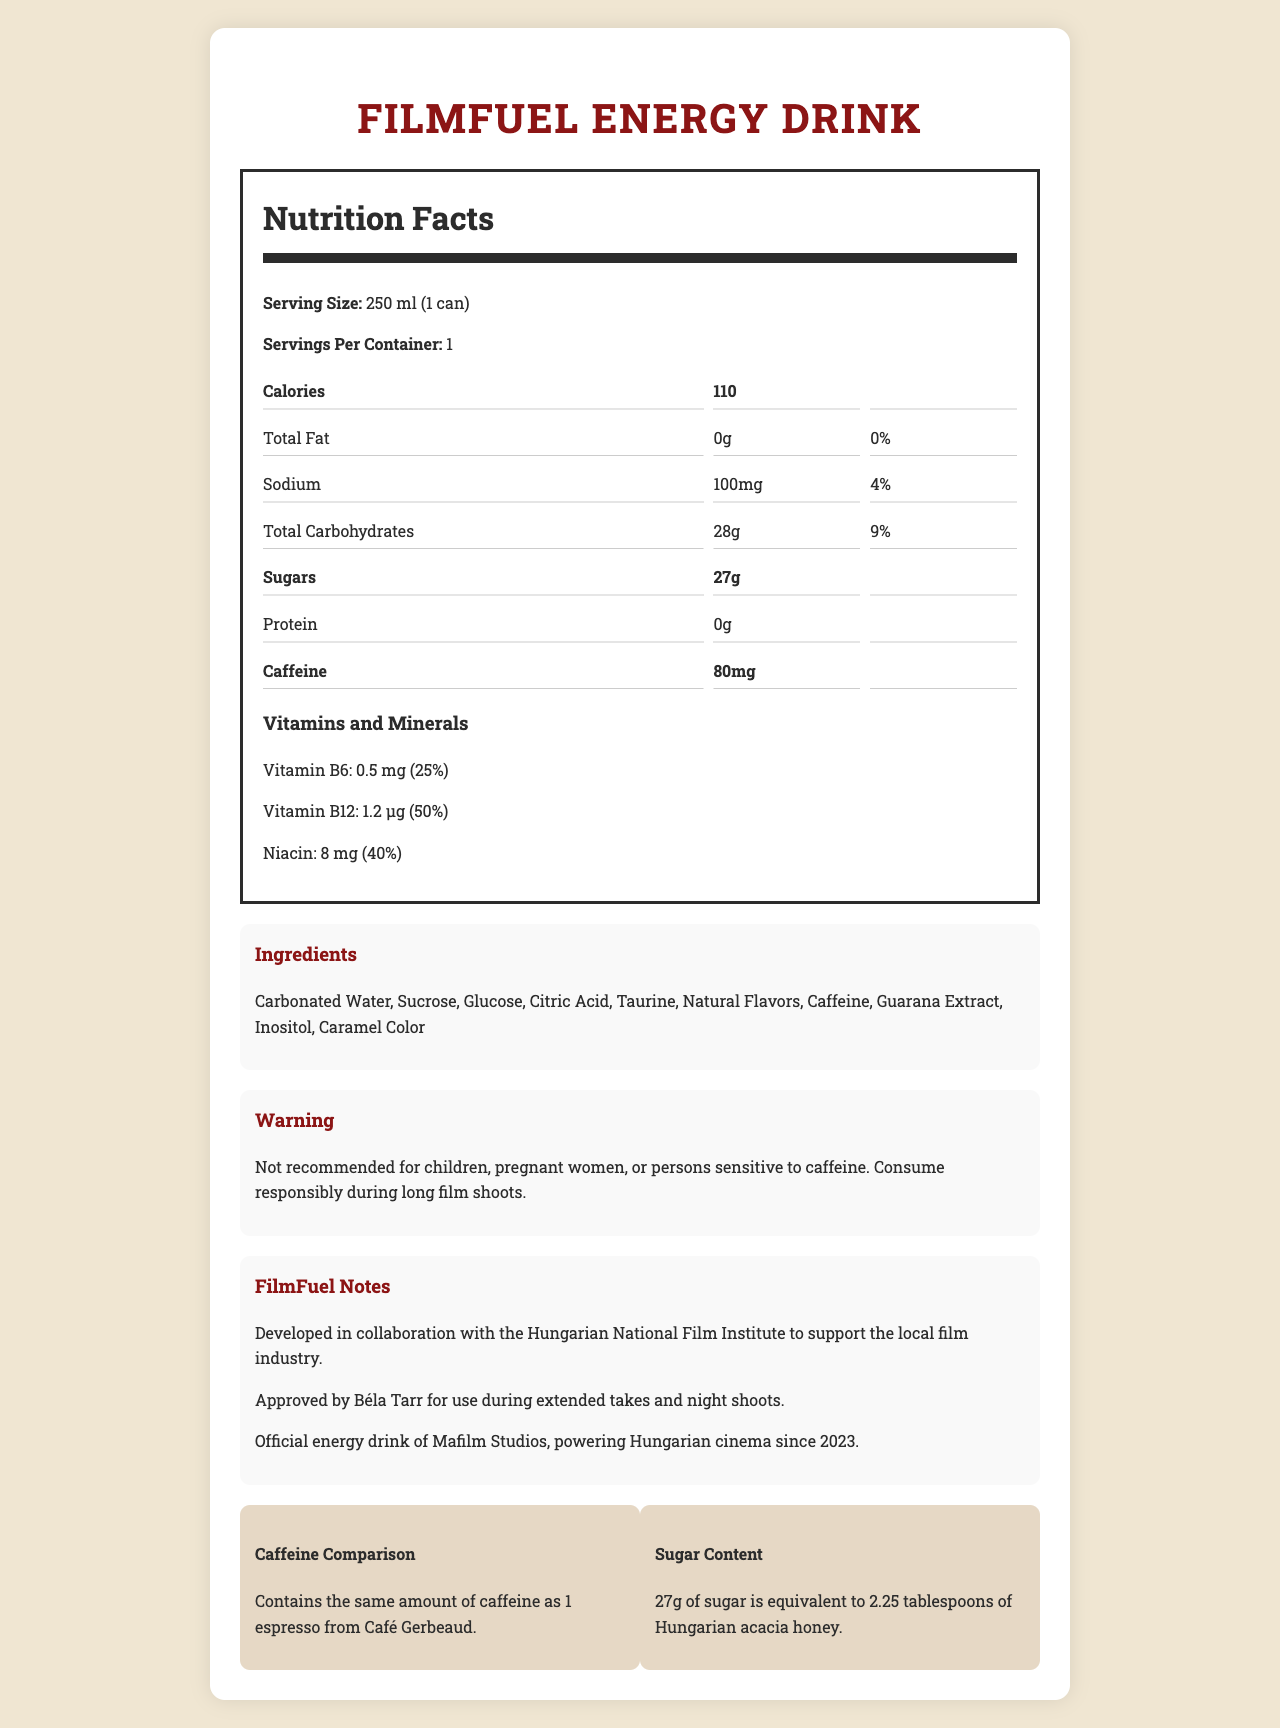How many milligrams of caffeine are in one serving of FilmFuel Energy Drink? The nutrition facts label clearly states that one serving of FilmFuel Energy Drink contains 80 mg of caffeine.
Answer: 80 mg What is the serving size of FilmFuel Energy Drink? The label specifies that the serving size is 250 ml, which is equivalent to one can.
Answer: 250 ml (1 can) How many grams of sugar are in one can of FilmFuel Energy Drink? According to the nutrition facts label, there are 27 grams of sugar in one can of FilmFuel Energy Drink.
Answer: 27 grams What percentage of the daily value of Vitamin B12 does one serving of FilmFuel Energy Drink provide? The nutrition facts label shows that one serving provides 50% of the daily value of Vitamin B12.
Answer: 50% What is one caution given about drinking FilmFuel Energy Drink? The warning section states that the drink is not recommended for children, pregnant women, or persons sensitive to caffeine.
Answer: Not recommended for children, pregnant women, or persons sensitive to caffeine. Which vitamin is present in the greatest amount by percentage of daily value in FilmFuel Energy Drink? The label shows that Vitamin B12 provides 50% of the daily value per serving, which is higher than the other vitamins listed.
Answer: Vitamin B12 How much sodium is there in one serving of FilmFuel Energy Drink? A. 50 mg B. 100 mg C. 150 mg D. 200 mg The nutrition facts indicate that there are 100 mg of sodium per serving.
Answer: B Which statement is correct about caffeine in the energy drink? A. It contains less caffeine than an espresso. B. It contains the same amount of caffeine as an espresso. C. It contains more caffeine than an espresso. The document states that the energy drink contains the same amount of caffeine as one espresso from Café Gerbeaud.
Answer: B Is FilmFuel Energy Drink suitable for use during extended takes and night shoots? The endorsement by Béla Tarr confirms that the energy drink is approved for use during extended takes and night shoots.
Answer: Yes Summarize the main information presented in the FilmFuel Energy Drink Nutrition Facts Label. The document includes nutrition specifics, ingredient lists, health warnings, and endorsements from the Hungarian National Film Institute, Béla Tarr, and Mafilm Studios. It emphasizes the caffeine and sugar content and their equivalents.
Answer: The FilmFuel Energy Drink Nutrition Facts Label presents detailed nutritional information for a 250 ml can, including calories, fats, sodium, carbohydrates, sugars, protein, and caffeine content. It also lists vitamins and minerals present, key ingredients, and safety warnings. Special notes highlight the drink’s development in collaboration with the Hungarian film industry and endorsements from notable film studios and directors. What is the significance of the partnership with Mafilm Studios? The document states that it is the official energy drink of Mafilm Studios, but it does not provide details on the significance or benefits of this partnership.
Answer: Not enough information 